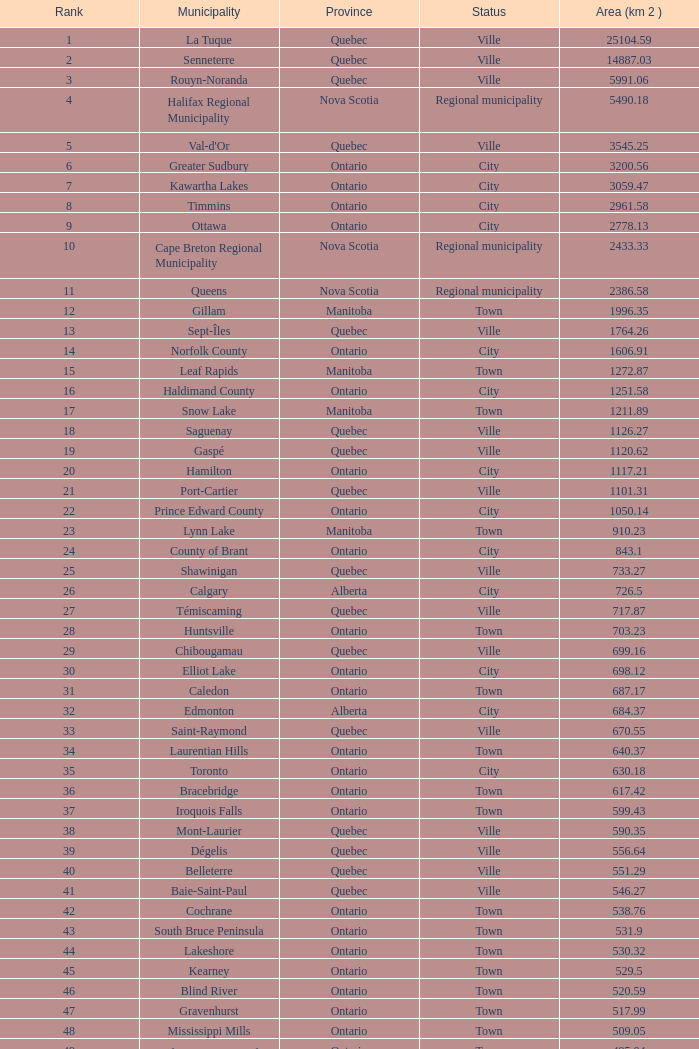What is the listed Status that has the Province of Ontario and Rank of 86? Town. 